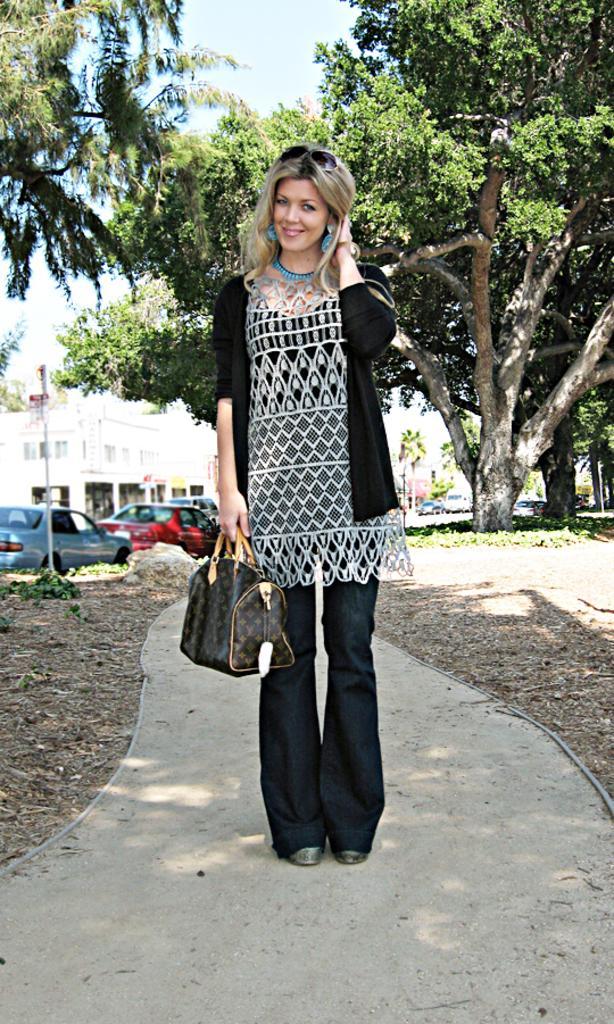In one or two sentences, can you explain what this image depicts? In this picture there is a lady at the center of the image, she is holding the bag in her hand, there are cars at the left side of the image and some trees around the image. 